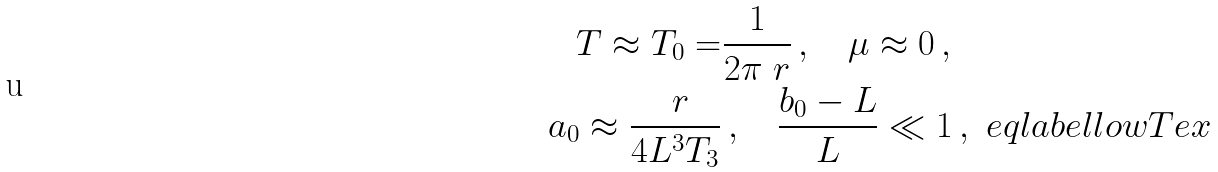<formula> <loc_0><loc_0><loc_500><loc_500>T \approx T _ { 0 } = & \frac { 1 } { 2 \pi \ r } \, , \quad \mu \approx 0 \, , \\ a _ { 0 } \approx \frac { \ r } { 4 L ^ { 3 } T _ { 3 } } & \, , \quad \frac { b _ { 0 } - L } { L } \ll 1 \, , \ e q l a b e l { l o w T e x }</formula> 